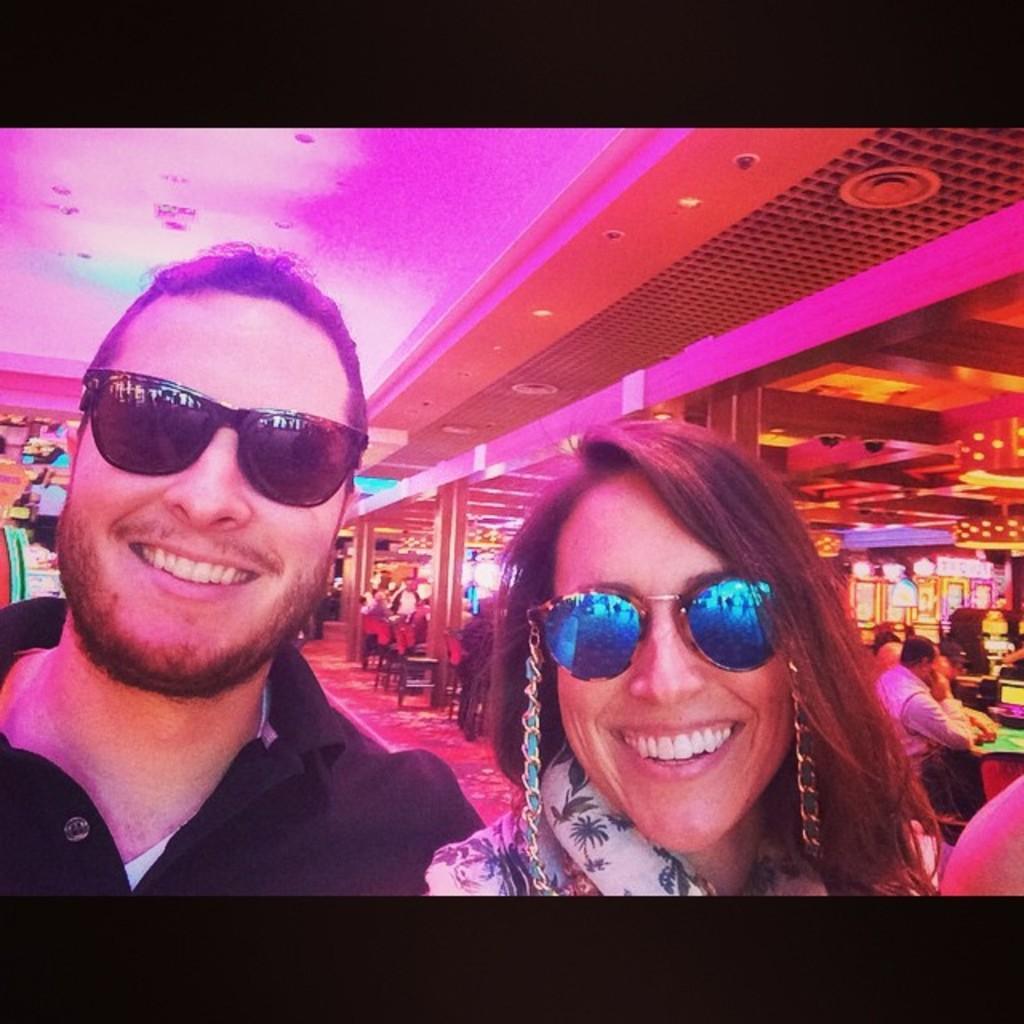Please provide a concise description of this image. In this picture we can see a man and a woman wore goggles and smiling and in the background we can see chairs, pillars, lights and some persons. 